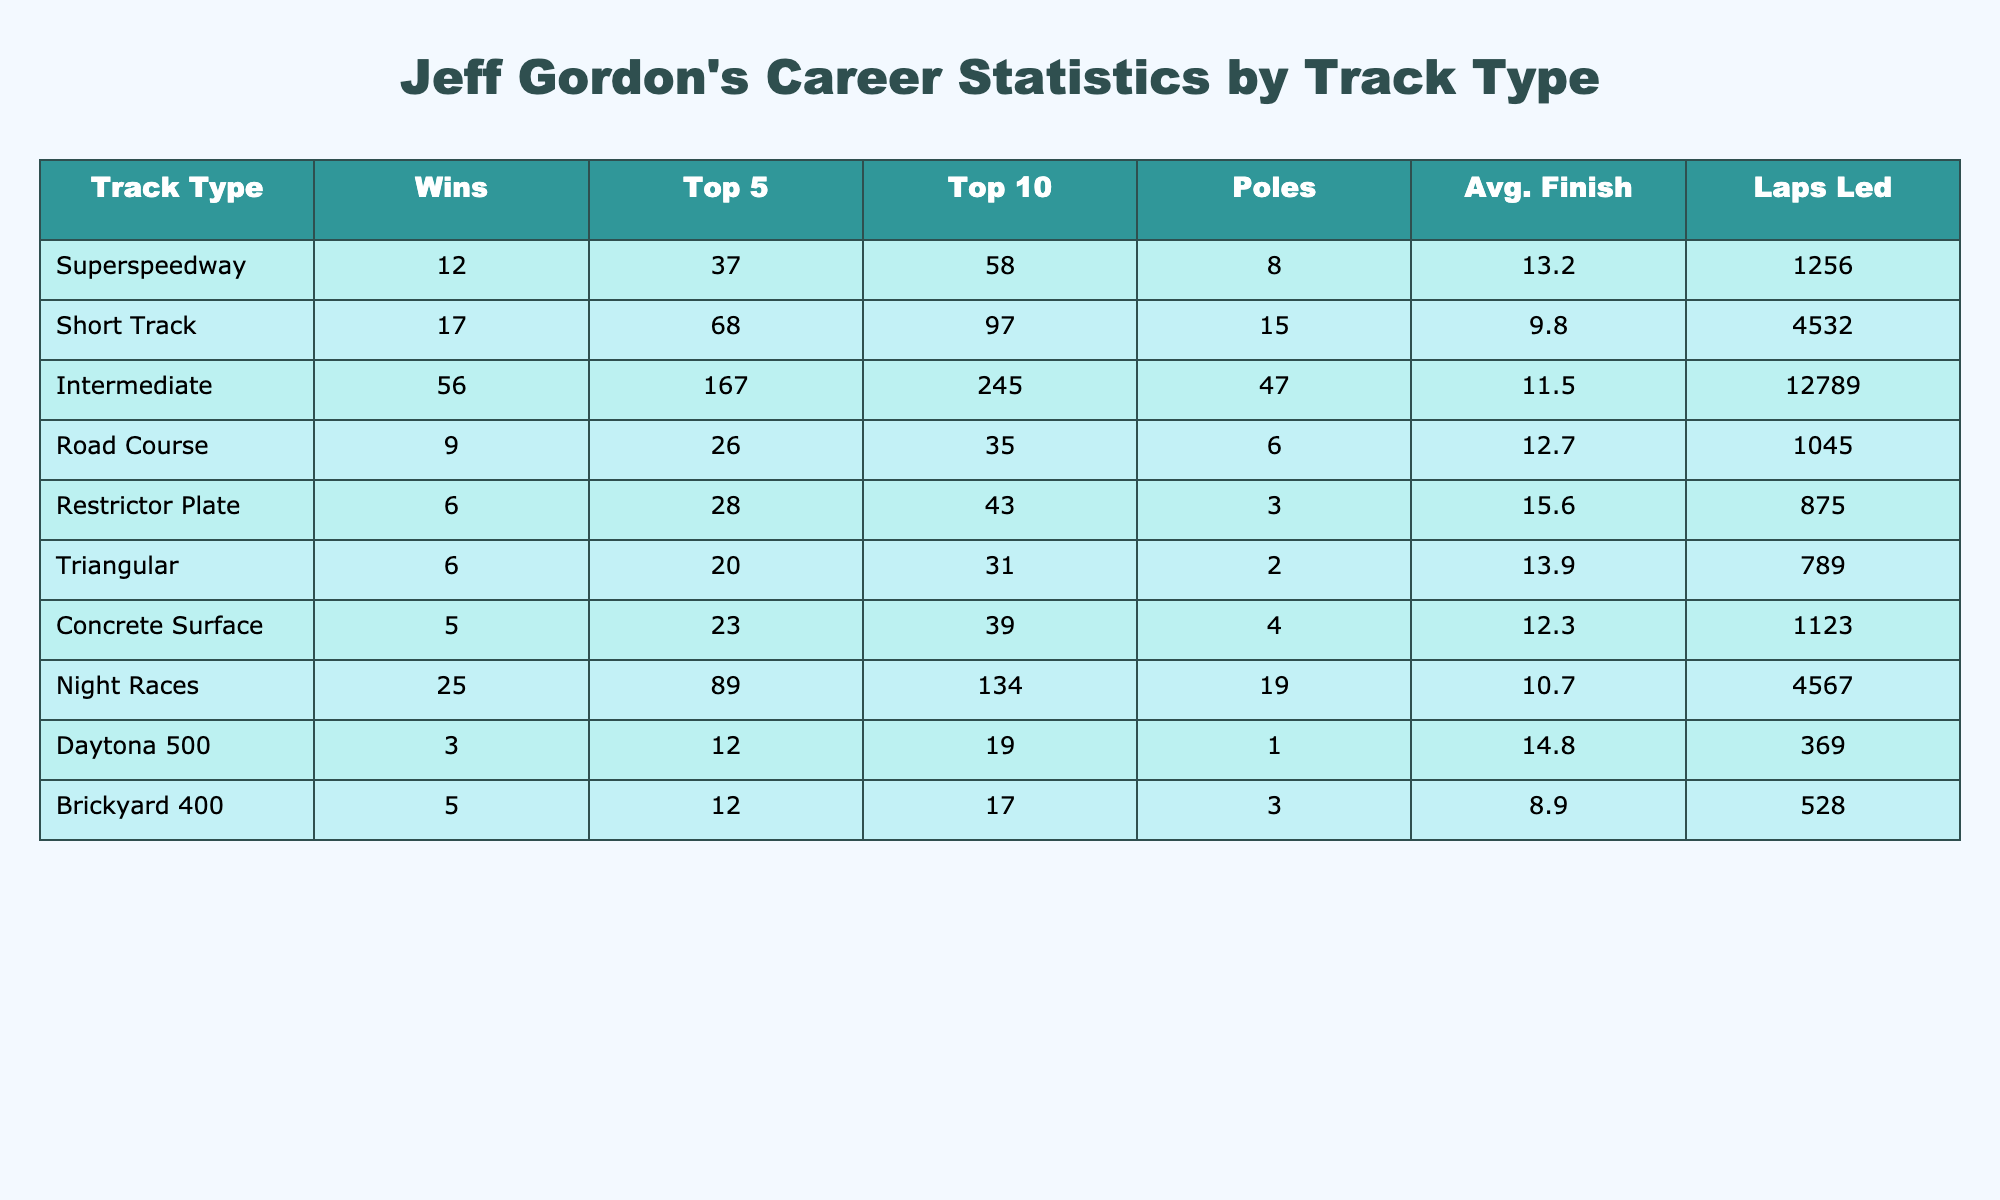What track type does Jeff Gordon have the most wins? By looking at the "Wins" column in the table, the highest number is 56, which corresponds to "Intermediate" track type.
Answer: Intermediate How many poles did Jeff Gordon secure at short tracks? The table shows that the number of poles for "Short Track" track type is 15.
Answer: 15 Which track type has the highest average finish position? The average finish position for each track type is listed, and the lowest number is 8.9 for "Brickyard 400," indicating it has the best average finish position among the listed types.
Answer: Brickyard 400 What is the total number of laps led by Jeff Gordon on road courses? From the table, the laps led in the "Road Course" category is 1045, which is directly listed in the Laps Led column.
Answer: 1045 How many more top 10 finishes did Gordon achieve in intermediate tracks compared to restrictor plate tracks? For "Intermediate" tracks, the top 10 finishes are 245, and for "Restrictor Plate," it’s 43. Calculating the difference: 245 - 43 = 202.
Answer: 202 Is Jeff Gordon's average finish position better on short tracks than on superspeedways? The average finish for "Short Track" is 9.8, while for "Superspeedway" it’s 13.2. Since 9.8 is less than 13.2, we conclude that it is better.
Answer: Yes What is the sum of Jeff Gordon's wins on triangular tracks and concrete surface tracks? The wins for "Triangular" tracks are 6 and for "Concrete Surface" tracks are 5. Adding these together gives 6 + 5 = 11.
Answer: 11 On which type of track did Gordon achieve the least number of poles? Comparing the "Poles" column, "Restrictor Plate" with 3 poles has the least.
Answer: Restrictor Plate What percentage of Jeff Gordon's total wins were achieved on intermediate tracks? The total wins across all track types is 12 + 17 + 56 + 9 + 6 + 6 + 5 + 25 + 3 + 5 = 144. The percentage of wins on "Intermediate" tracks (which is 56) is (56 / 144) * 100 = 38.89%.
Answer: 38.89% Which track type has the highest number of top 5 finishes for Jeff Gordon? Referring to the "Top 5" column, "Intermediate" tracks have the highest count at 167.
Answer: Intermediate 